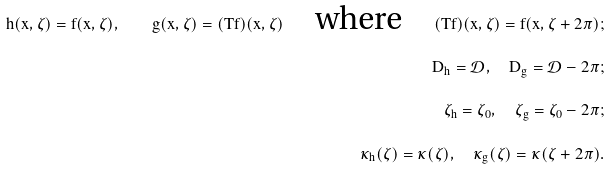<formula> <loc_0><loc_0><loc_500><loc_500>h ( x , \zeta ) = f ( x , \zeta ) , \quad g ( x , \zeta ) = ( T f ) ( x , \zeta ) \quad \text {where} \quad ( T f ) ( x , \zeta ) = f ( x , \zeta + 2 \pi ) ; \\ D _ { h } = \mathcal { D } , \quad D _ { g } = \mathcal { D } - 2 \pi ; \\ \zeta _ { h } = \zeta _ { 0 } , \quad \zeta _ { g } = \zeta _ { 0 } - 2 \pi ; \\ \kappa _ { h } ( \zeta ) = \kappa ( \zeta ) , \quad \kappa _ { g } ( \zeta ) = \kappa ( \zeta + 2 \pi ) .</formula> 